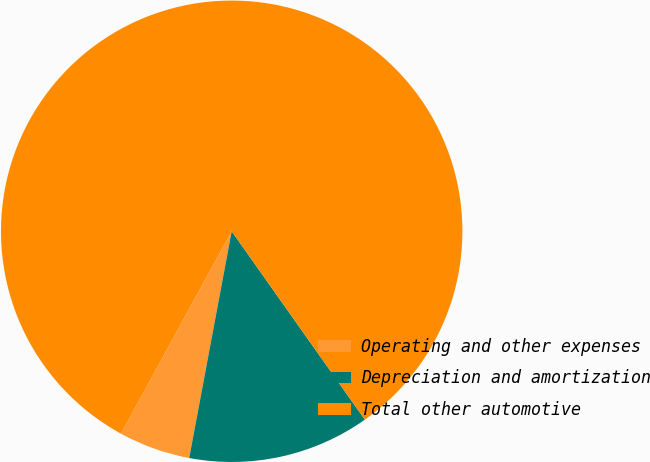<chart> <loc_0><loc_0><loc_500><loc_500><pie_chart><fcel>Operating and other expenses<fcel>Depreciation and amortization<fcel>Total other automotive<nl><fcel>5.02%<fcel>12.74%<fcel>82.24%<nl></chart> 